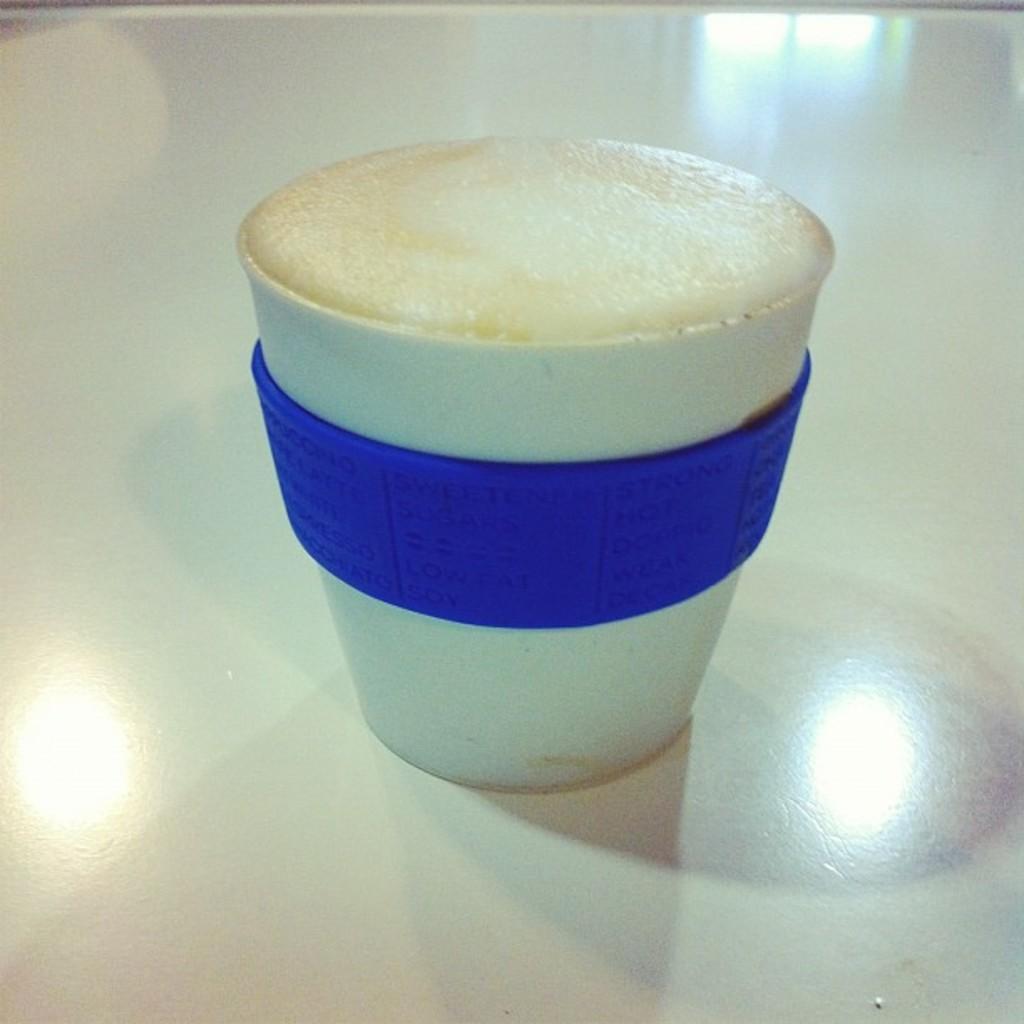How would you summarize this image in a sentence or two? In this image I can see the white colored surface and on it I can see a cup which is white and blue in color with a liquid in it which is cream in color. 